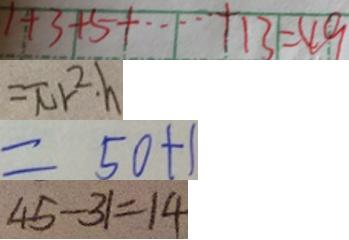<formula> <loc_0><loc_0><loc_500><loc_500>1 + 3 + 5 + \cdots + 1 3 + 4 9 
 = \pi r ^ { 2 } \cdot h 
 = 5 0 + 1 
 4 5 - 3 1 = 1 4</formula> 